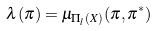<formula> <loc_0><loc_0><loc_500><loc_500>\lambda ( \pi ) & = \mu _ { \Pi _ { l } ( X ) } ( \pi , \pi ^ { * } )</formula> 